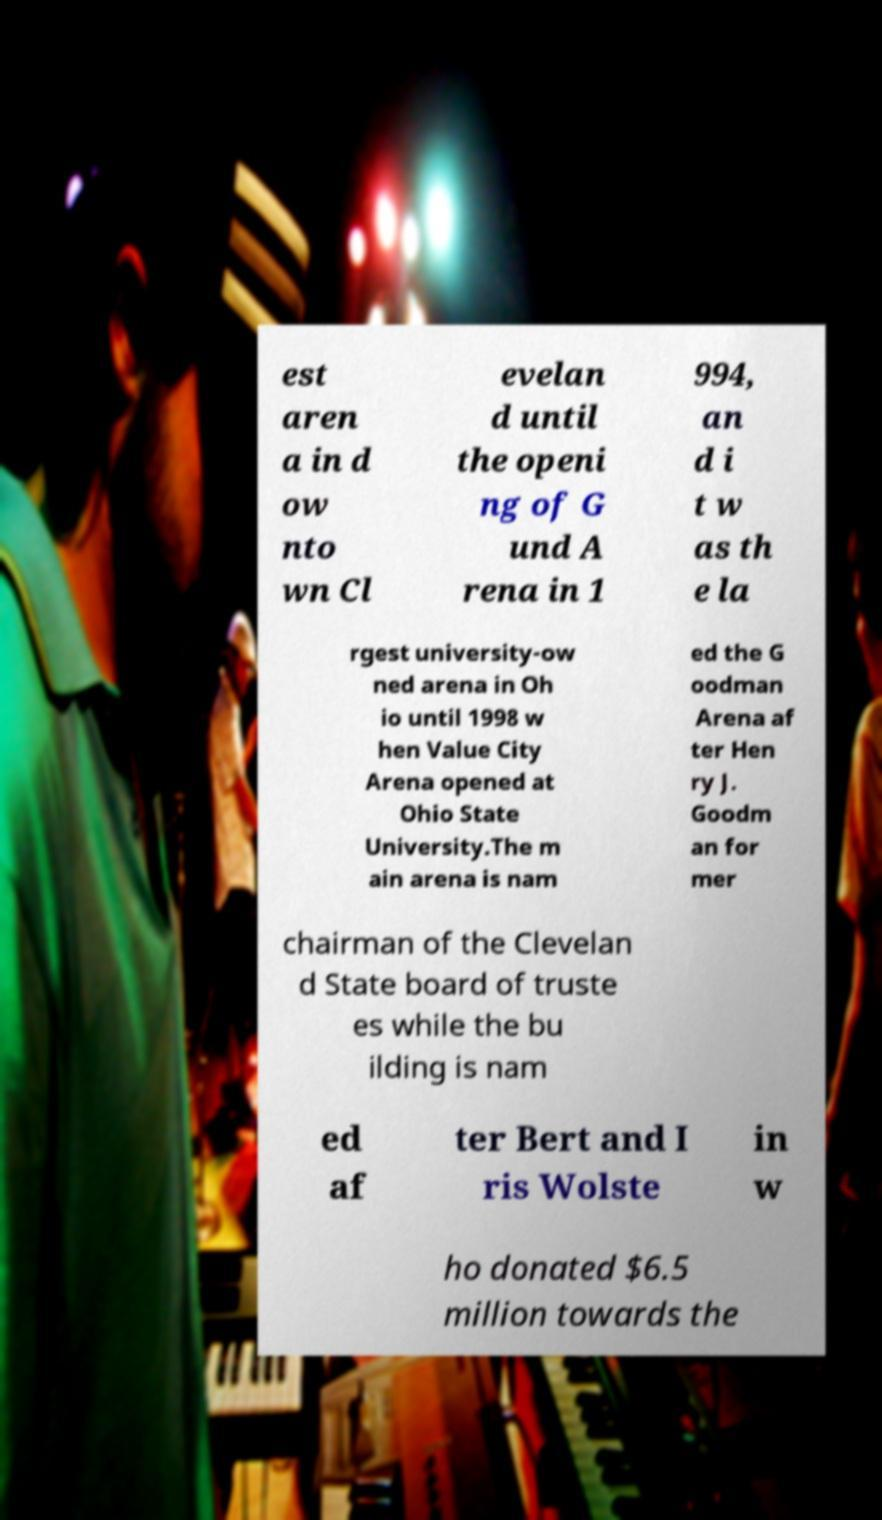For documentation purposes, I need the text within this image transcribed. Could you provide that? est aren a in d ow nto wn Cl evelan d until the openi ng of G und A rena in 1 994, an d i t w as th e la rgest university-ow ned arena in Oh io until 1998 w hen Value City Arena opened at Ohio State University.The m ain arena is nam ed the G oodman Arena af ter Hen ry J. Goodm an for mer chairman of the Clevelan d State board of truste es while the bu ilding is nam ed af ter Bert and I ris Wolste in w ho donated $6.5 million towards the 